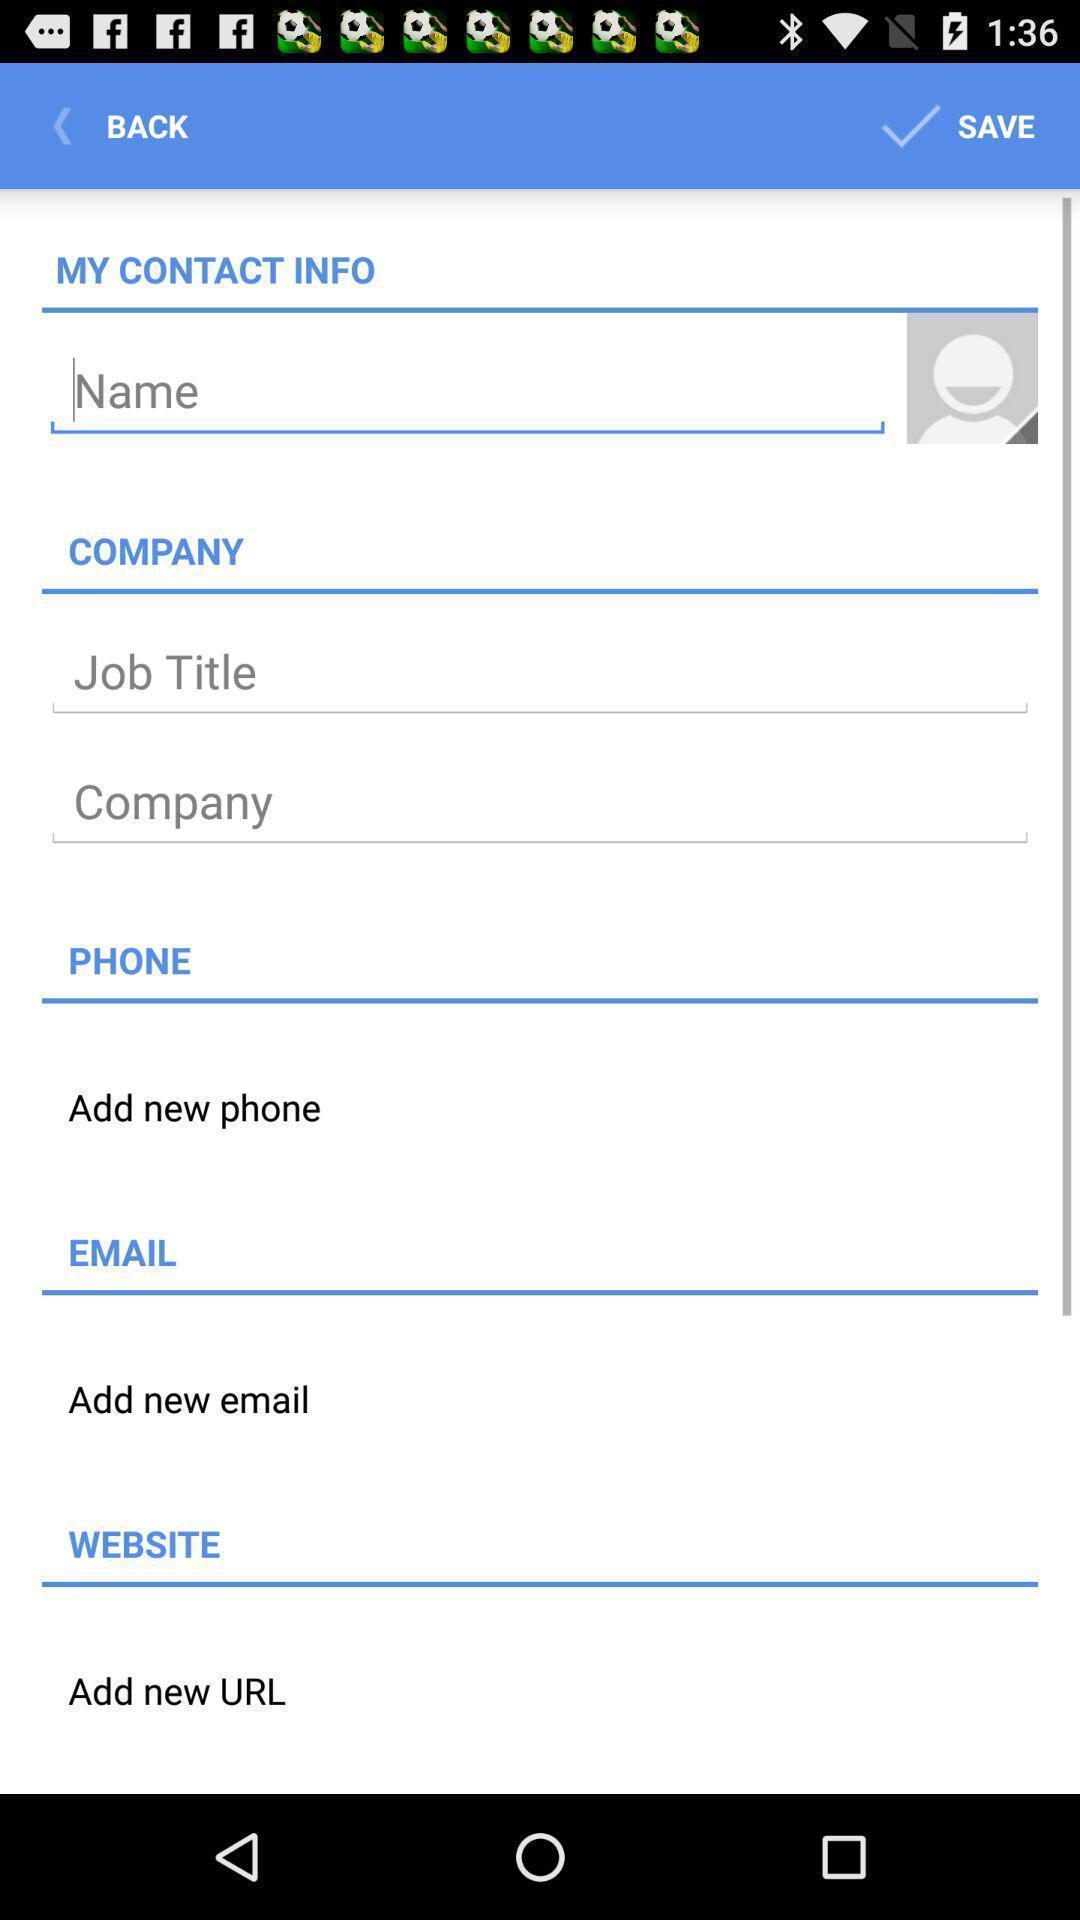What is the overall content of this screenshot? Text boxes to enter the profile details in the app. 